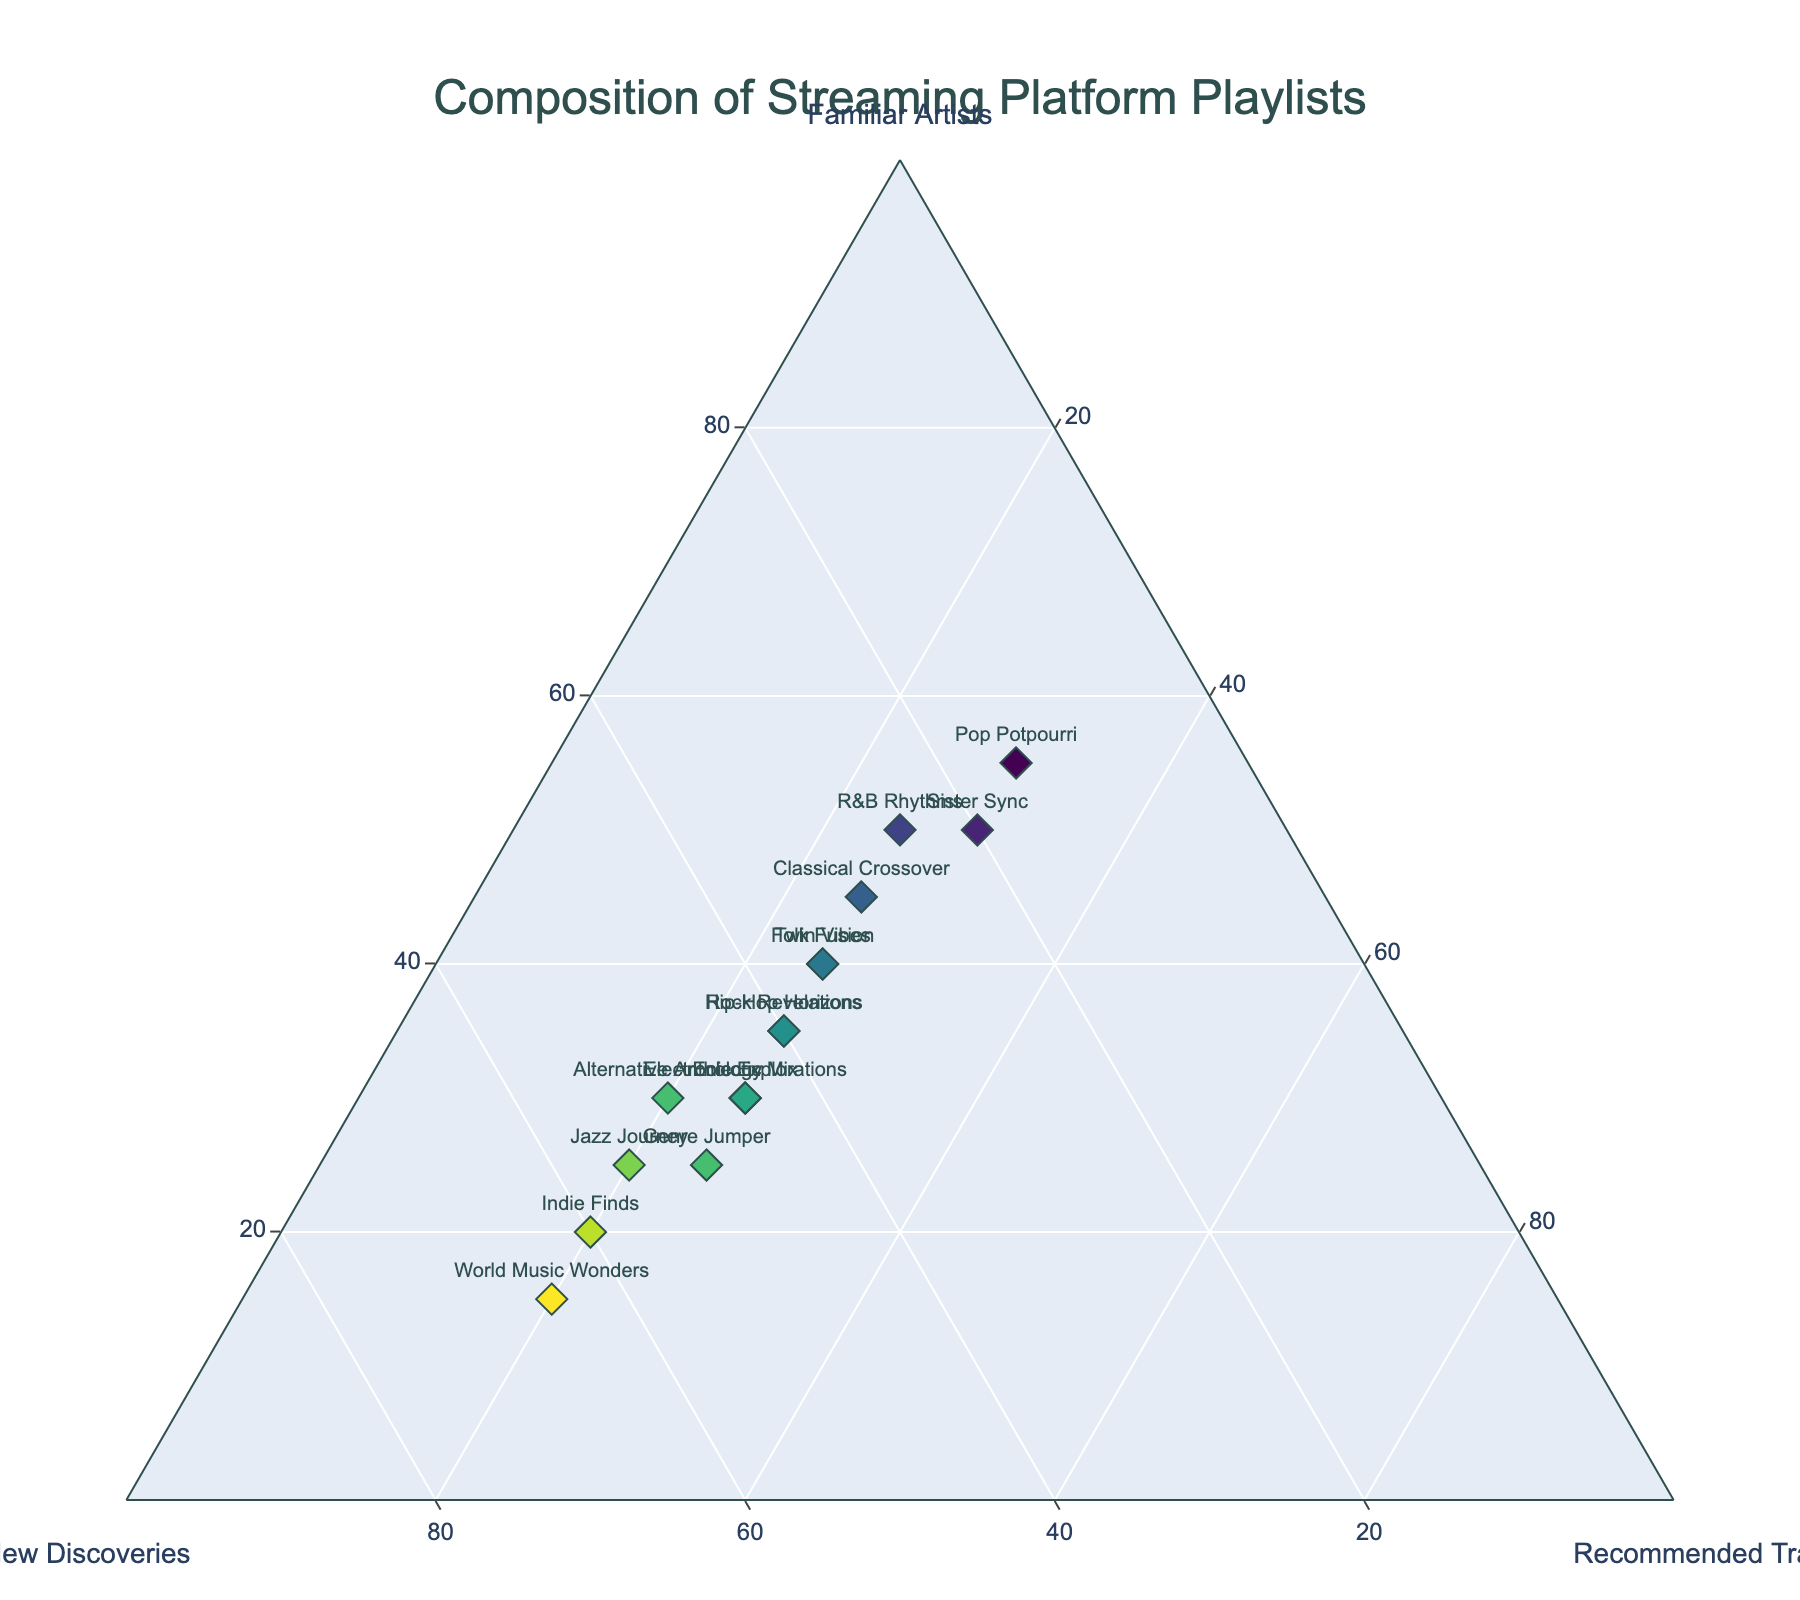Which playlist has the highest percentage of new discoveries? Look for the data point farthest along the 'New Discoveries' axis. 'World Music Wonders' has the highest value of 65 for new discoveries.
Answer: World Music Wonders What is the title of the plot? Read the title displayed at the top of the plot. The title "Composition of Streaming Platform Playlists" is clearly shown.
Answer: Composition of Streaming Platform Playlists Which playlists have an equal percentage of recommended tracks? Look for data points that have the same value on the 'Recommended Tracks' axis. 'Twin Vibes', 'Eclectic Mix', 'Rock Revelations', 'Electronic Explorations', 'Hip-Hop Horizons', and 'R&B Rhythms' all have 25% recommended tracks.
Answer: Twin Vibes, Eclectic Mix, Rock Revelations, Electronic Explorations, Hip-Hop Horizons, R&B Rhythms How many playlists have a higher percentage of familiar artists than new discoveries? Compare the values for 'Familiar Artists' and 'New Discoveries' for each playlist. There are six playlists: 'Twin Vibes', 'Sister Sync', 'Pop Potpourri', 'Folk Fusion', 'Classical Crossover', and 'R&B Rhythms'.
Answer: 6 What is the relationship between 'Genre Jumper' and 'Alternative Anthology' in terms of familiar artists and new discoveries? Both 'Genre Jumper' and 'Alternative Anthology' have the same value for familiar artists (30) and new discoveries (50) respectively. They are identical in these two aspects.
Answer: Identical What is the lowest percentage of familiar artists among the playlists? Find the data point closest to 0% on the 'Familiar Artists' axis. 'World Music Wonders' has the lowest percentage of familiar artists at 15%.
Answer: 15% If we sum the percentages of familiar artists and recommended tracks for 'Folk Fusion', what do we get? Add 40% (Familiar Artists) and 25% (Recommended Tracks) as read from the plot. The total is 40 + 25 = 65.
Answer: 65 Which playlist has exactly 30% familiar artists? Find the data point along the 'Familiar Artists' axis with the value of 30. 'Eclectic Mix', 'Electronic Explorations', and 'Alternative Anthology' each have 30% familiar artists.
Answer: Eclectic Mix, Electronic Explorations, Alternative Anthology Which playlist shows the most balanced composition across the three categories? Look for a point where the percentages are relatively close to each other. 'Twin Vibes' has 40% familiar artists, 35% new discoveries, and 25% recommended tracks, making it relatively balanced.
Answer: Twin Vibes 